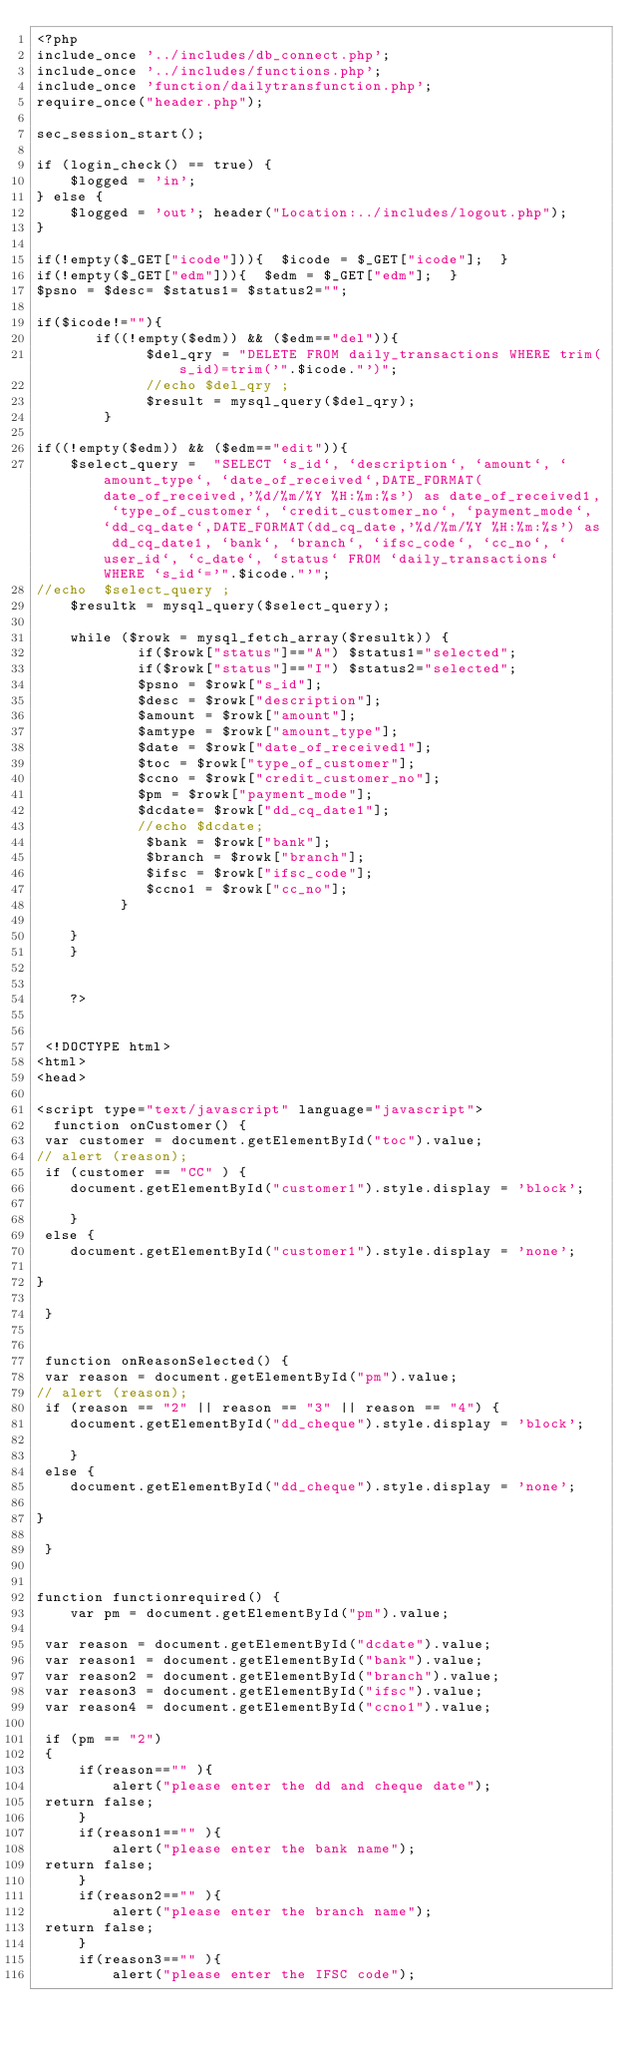<code> <loc_0><loc_0><loc_500><loc_500><_PHP_><?php 
include_once '../includes/db_connect.php';
include_once '../includes/functions.php';
include_once 'function/dailytransfunction.php';
require_once("header.php");

sec_session_start();

if (login_check() == true) {
    $logged = 'in';
} else {
    $logged = 'out'; header("Location:../includes/logout.php");
}

if(!empty($_GET["icode"])){  $icode = $_GET["icode"];  }
if(!empty($_GET["edm"])){  $edm = $_GET["edm"];  }
$psno = $desc= $status1= $status2="";
	
if($icode!=""){
	   if((!empty($edm)) && ($edm=="del")){   
		     $del_qry = "DELETE FROM daily_transactions WHERE trim(s_id)=trim('".$icode."')";
			 //echo $del_qry ;
			 $result = mysql_query($del_qry);
	  	}
	 
if((!empty($edm)) && ($edm=="edit")){   
	$select_query =  "SELECT `s_id`, `description`, `amount`, `amount_type`, `date_of_received`,DATE_FORMAT(date_of_received,'%d/%m/%Y %H:%m:%s') as date_of_received1, `type_of_customer`, `credit_customer_no`, `payment_mode`, `dd_cq_date`,DATE_FORMAT(dd_cq_date,'%d/%m/%Y %H:%m:%s') as dd_cq_date1, `bank`, `branch`, `ifsc_code`, `cc_no`, `user_id`, `c_date`, `status` FROM `daily_transactions` WHERE `s_id`='".$icode."'";
//echo  $select_query ;
	$resultk = mysql_query($select_query);

	while ($rowk = mysql_fetch_array($resultk)) {
			if($rowk["status"]=="A") $status1="selected";
			if($rowk["status"]=="I") $status2="selected";
			$psno = $rowk["s_id"];
			$desc = $rowk["description"]; 
			$amount = $rowk["amount"];
			$amtype = $rowk["amount_type"];
			$date = $rowk["date_of_received1"];
			$toc = $rowk["type_of_customer"];
			$ccno = $rowk["credit_customer_no"];
			$pm = $rowk["payment_mode"];
			$dcdate= $rowk["dd_cq_date1"];
			//echo $dcdate;
			 $bank = $rowk["bank"];
			 $branch = $rowk["branch"];
			 $ifsc = $rowk["ifsc_code"];
			 $ccno1 = $rowk["cc_no"];
		  }
		
	}
	}
	
	
	?>
	
	
 <!DOCTYPE html>
<html>
<head> 

<script type="text/javascript" language="javascript">
  function onCustomer() {
 var customer = document.getElementById("toc").value;
// alert (reason);
 if (customer == "CC" ) {
	document.getElementById("customer1").style.display = 'block';
	
	}
 else {
	document.getElementById("customer1").style.display = 'none';
	
}

 }
 
 
 function onReasonSelected() {
 var reason = document.getElementById("pm").value;
// alert (reason);
 if (reason == "2" || reason == "3" || reason == "4") {
	document.getElementById("dd_cheque").style.display = 'block';
	
	}
 else {
	document.getElementById("dd_cheque").style.display = 'none';
	
}

 }
 
 
function functionrequired() {
	var pm = document.getElementById("pm").value;

 var reason = document.getElementById("dcdate").value;
 var reason1 = document.getElementById("bank").value;
 var reason2 = document.getElementById("branch").value;
 var reason3 = document.getElementById("ifsc").value;
 var reason4 = document.getElementById("ccno1").value;

 if (pm == "2")
 {
	 if(reason=="" ){
		 alert("please enter the dd and cheque date");
 return false;
	 }
	 if(reason1=="" ){
		 alert("please enter the bank name");
 return false;
	 }
	 if(reason2=="" ){
		 alert("please enter the branch name");
 return false;
	 }
	 if(reason3=="" ){
		 alert("please enter the IFSC code");</code> 